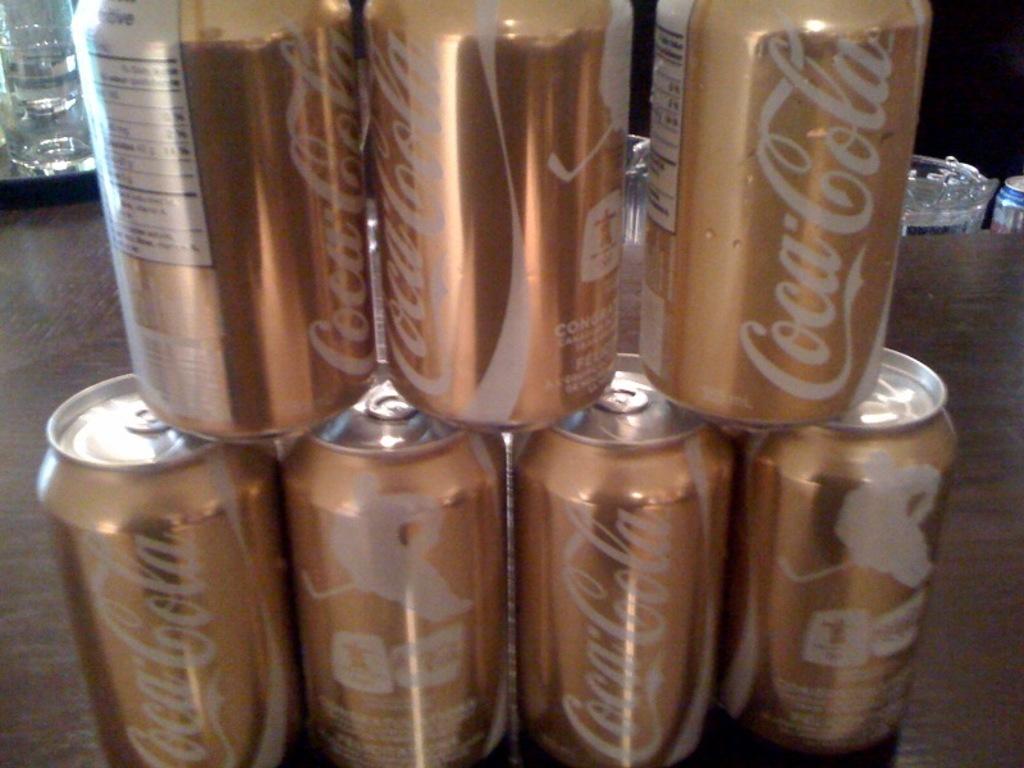What brand of soda cans are stacked on top of one another?
Provide a short and direct response. Coca cola. What are the first 3 letters of the word at the bottom of the middle can?
Offer a terse response. Con. 